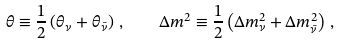Convert formula to latex. <formula><loc_0><loc_0><loc_500><loc_500>\theta \equiv \frac { 1 } { 2 } \left ( \theta _ { \nu } + \theta _ { \bar { \nu } } \right ) \, , \quad \Delta m ^ { 2 } \equiv \frac { 1 } { 2 } \left ( \Delta m _ { \nu } ^ { 2 } + \Delta m _ { \bar { \nu } } ^ { 2 } \right ) \, ,</formula> 